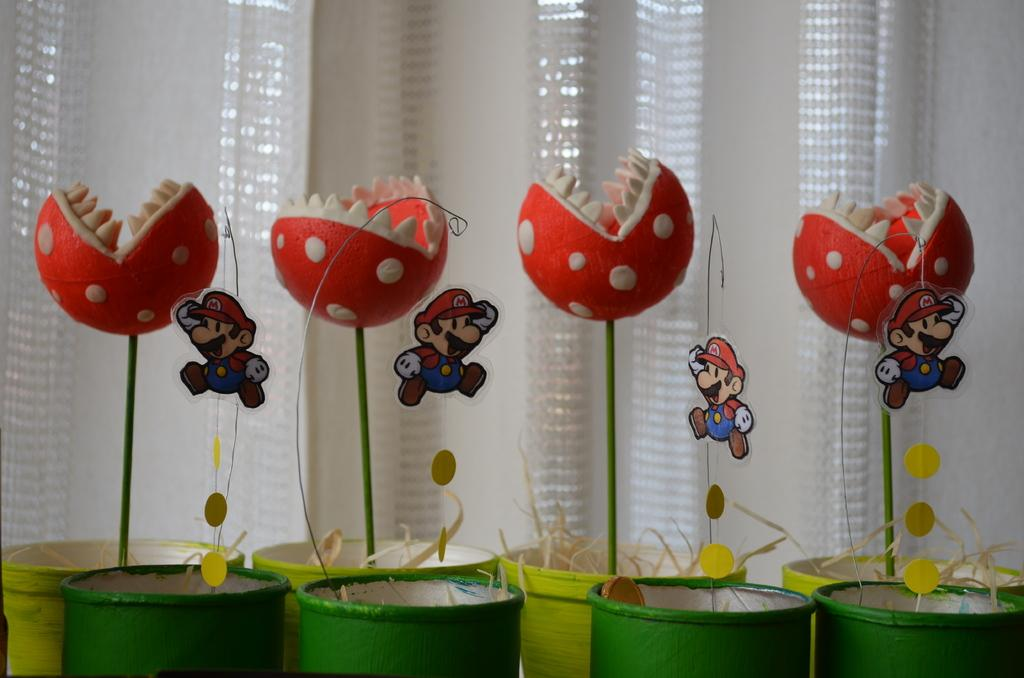What objects are present in the image that are typically used for play? There are toys in the image. What objects are present in the image that are typically used for holding liquids? There are cups in the image. What objects are present in the background of the image that are typically used for covering windows? There are curtains in the background of the image. What type of drink is being poured from the feather in the image? There is no feather present in the image, and therefore no drink being poured from it. 